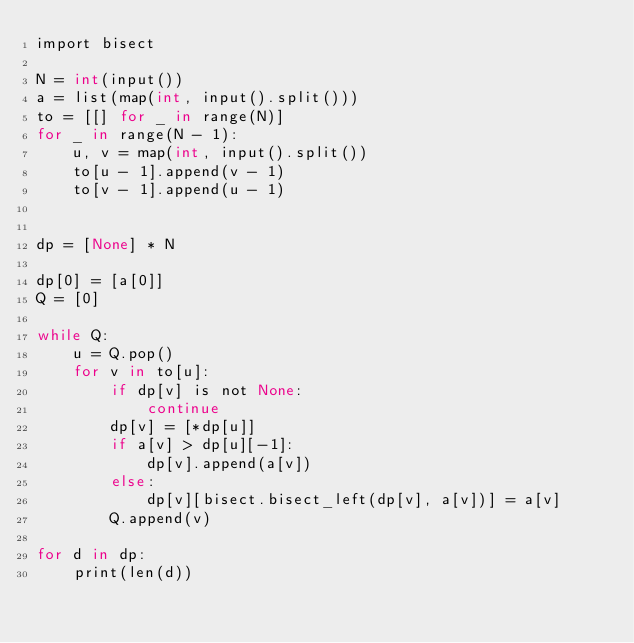Convert code to text. <code><loc_0><loc_0><loc_500><loc_500><_Cython_>import bisect

N = int(input())
a = list(map(int, input().split()))
to = [[] for _ in range(N)]
for _ in range(N - 1):
    u, v = map(int, input().split())
    to[u - 1].append(v - 1)
    to[v - 1].append(u - 1)


dp = [None] * N

dp[0] = [a[0]]
Q = [0]

while Q:
    u = Q.pop()
    for v in to[u]:
        if dp[v] is not None:
            continue
        dp[v] = [*dp[u]]
        if a[v] > dp[u][-1]:
            dp[v].append(a[v])
        else:
            dp[v][bisect.bisect_left(dp[v], a[v])] = a[v]
        Q.append(v)

for d in dp:
    print(len(d))
</code> 